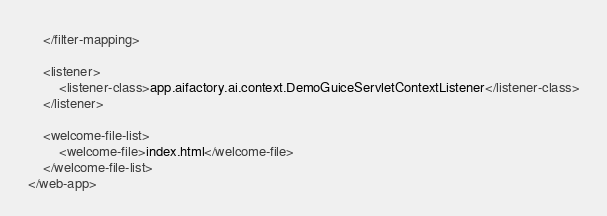Convert code to text. <code><loc_0><loc_0><loc_500><loc_500><_XML_>    </filter-mapping>

    <listener>
        <listener-class>app.aifactory.ai.context.DemoGuiceServletContextListener</listener-class>
    </listener>

    <welcome-file-list>
        <welcome-file>index.html</welcome-file>
    </welcome-file-list>
</web-app>
</code> 